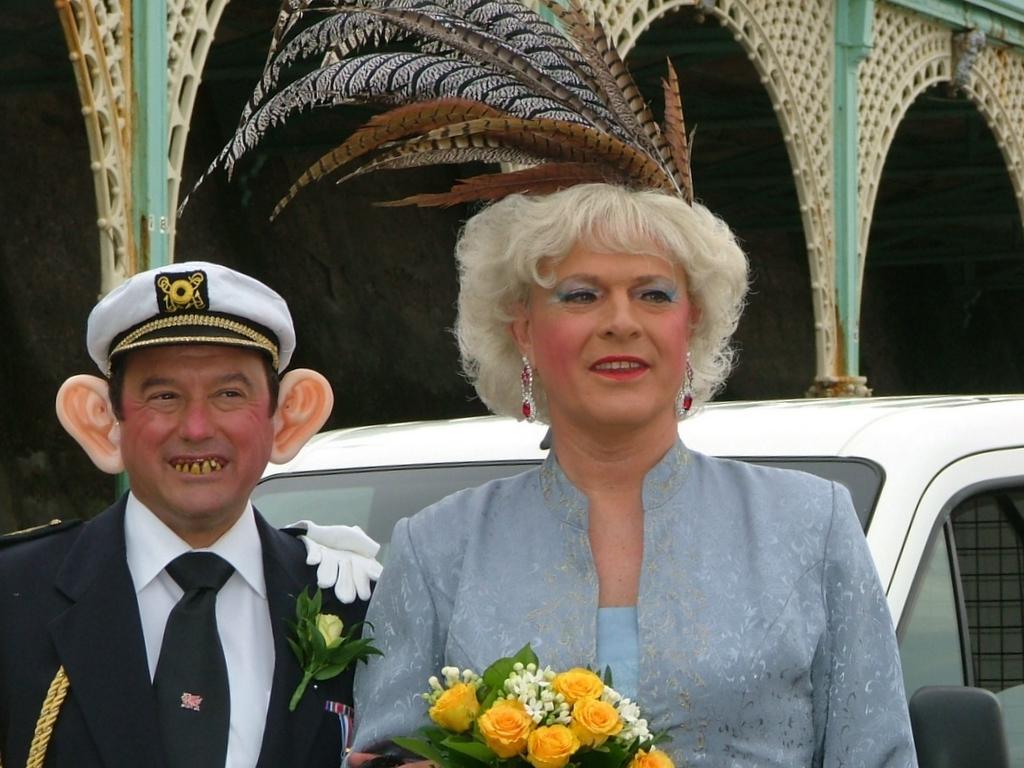Could you give a brief overview of what you see in this image? In this image there is a woman holding a flower bouquet in her hand, inside the woman there is a person standing, behind them there is a car and behind the car there are pillars. 